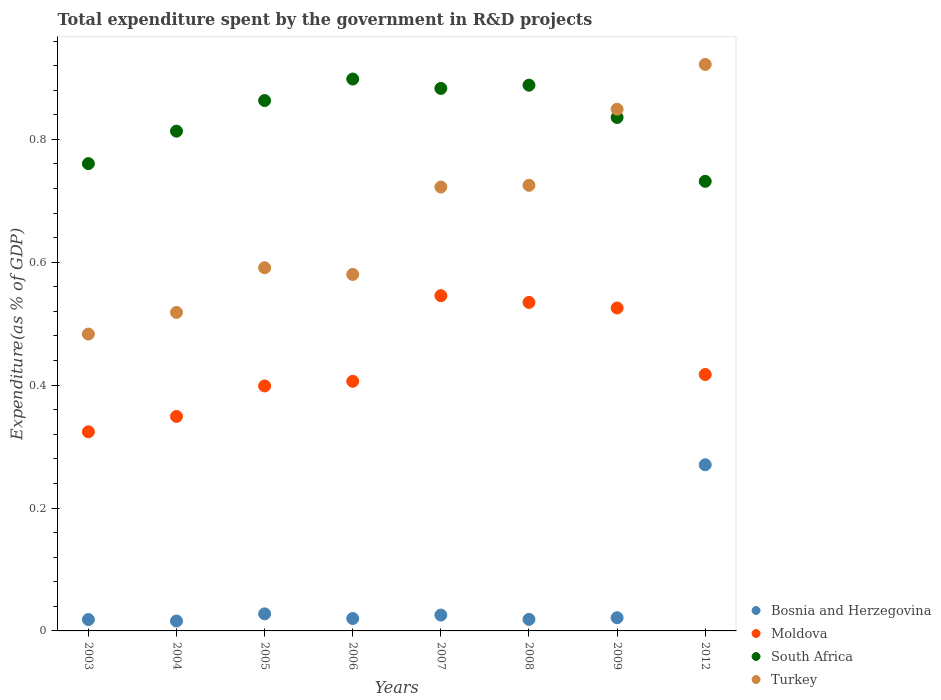What is the total expenditure spent by the government in R&D projects in Turkey in 2007?
Provide a short and direct response. 0.72. Across all years, what is the maximum total expenditure spent by the government in R&D projects in Turkey?
Your response must be concise. 0.92. Across all years, what is the minimum total expenditure spent by the government in R&D projects in Moldova?
Your answer should be very brief. 0.32. In which year was the total expenditure spent by the government in R&D projects in Turkey maximum?
Your answer should be compact. 2012. In which year was the total expenditure spent by the government in R&D projects in Turkey minimum?
Keep it short and to the point. 2003. What is the total total expenditure spent by the government in R&D projects in South Africa in the graph?
Give a very brief answer. 6.67. What is the difference between the total expenditure spent by the government in R&D projects in Bosnia and Herzegovina in 2004 and that in 2012?
Make the answer very short. -0.25. What is the difference between the total expenditure spent by the government in R&D projects in Turkey in 2005 and the total expenditure spent by the government in R&D projects in Moldova in 2008?
Ensure brevity in your answer.  0.06. What is the average total expenditure spent by the government in R&D projects in Turkey per year?
Give a very brief answer. 0.67. In the year 2005, what is the difference between the total expenditure spent by the government in R&D projects in Moldova and total expenditure spent by the government in R&D projects in South Africa?
Your response must be concise. -0.46. In how many years, is the total expenditure spent by the government in R&D projects in South Africa greater than 0.08 %?
Ensure brevity in your answer.  8. What is the ratio of the total expenditure spent by the government in R&D projects in South Africa in 2004 to that in 2009?
Ensure brevity in your answer.  0.97. Is the total expenditure spent by the government in R&D projects in Bosnia and Herzegovina in 2005 less than that in 2008?
Your answer should be very brief. No. What is the difference between the highest and the second highest total expenditure spent by the government in R&D projects in Moldova?
Your answer should be very brief. 0.01. What is the difference between the highest and the lowest total expenditure spent by the government in R&D projects in Moldova?
Your answer should be very brief. 0.22. In how many years, is the total expenditure spent by the government in R&D projects in Bosnia and Herzegovina greater than the average total expenditure spent by the government in R&D projects in Bosnia and Herzegovina taken over all years?
Your answer should be very brief. 1. Is it the case that in every year, the sum of the total expenditure spent by the government in R&D projects in South Africa and total expenditure spent by the government in R&D projects in Bosnia and Herzegovina  is greater than the sum of total expenditure spent by the government in R&D projects in Moldova and total expenditure spent by the government in R&D projects in Turkey?
Provide a short and direct response. No. Is it the case that in every year, the sum of the total expenditure spent by the government in R&D projects in Turkey and total expenditure spent by the government in R&D projects in South Africa  is greater than the total expenditure spent by the government in R&D projects in Bosnia and Herzegovina?
Provide a succinct answer. Yes. Is the total expenditure spent by the government in R&D projects in Moldova strictly greater than the total expenditure spent by the government in R&D projects in Turkey over the years?
Keep it short and to the point. No. How many years are there in the graph?
Your answer should be very brief. 8. What is the difference between two consecutive major ticks on the Y-axis?
Your answer should be compact. 0.2. Are the values on the major ticks of Y-axis written in scientific E-notation?
Give a very brief answer. No. How many legend labels are there?
Provide a succinct answer. 4. What is the title of the graph?
Your response must be concise. Total expenditure spent by the government in R&D projects. Does "Chad" appear as one of the legend labels in the graph?
Offer a terse response. No. What is the label or title of the X-axis?
Make the answer very short. Years. What is the label or title of the Y-axis?
Make the answer very short. Expenditure(as % of GDP). What is the Expenditure(as % of GDP) of Bosnia and Herzegovina in 2003?
Offer a terse response. 0.02. What is the Expenditure(as % of GDP) in Moldova in 2003?
Your response must be concise. 0.32. What is the Expenditure(as % of GDP) in South Africa in 2003?
Keep it short and to the point. 0.76. What is the Expenditure(as % of GDP) of Turkey in 2003?
Ensure brevity in your answer.  0.48. What is the Expenditure(as % of GDP) in Bosnia and Herzegovina in 2004?
Provide a short and direct response. 0.02. What is the Expenditure(as % of GDP) of Moldova in 2004?
Your response must be concise. 0.35. What is the Expenditure(as % of GDP) in South Africa in 2004?
Provide a short and direct response. 0.81. What is the Expenditure(as % of GDP) in Turkey in 2004?
Make the answer very short. 0.52. What is the Expenditure(as % of GDP) of Bosnia and Herzegovina in 2005?
Keep it short and to the point. 0.03. What is the Expenditure(as % of GDP) in Moldova in 2005?
Provide a succinct answer. 0.4. What is the Expenditure(as % of GDP) in South Africa in 2005?
Offer a very short reply. 0.86. What is the Expenditure(as % of GDP) of Turkey in 2005?
Provide a succinct answer. 0.59. What is the Expenditure(as % of GDP) of Bosnia and Herzegovina in 2006?
Offer a terse response. 0.02. What is the Expenditure(as % of GDP) of Moldova in 2006?
Give a very brief answer. 0.41. What is the Expenditure(as % of GDP) of South Africa in 2006?
Provide a succinct answer. 0.9. What is the Expenditure(as % of GDP) in Turkey in 2006?
Offer a very short reply. 0.58. What is the Expenditure(as % of GDP) of Bosnia and Herzegovina in 2007?
Make the answer very short. 0.03. What is the Expenditure(as % of GDP) in Moldova in 2007?
Ensure brevity in your answer.  0.55. What is the Expenditure(as % of GDP) of South Africa in 2007?
Provide a short and direct response. 0.88. What is the Expenditure(as % of GDP) of Turkey in 2007?
Offer a very short reply. 0.72. What is the Expenditure(as % of GDP) in Bosnia and Herzegovina in 2008?
Provide a short and direct response. 0.02. What is the Expenditure(as % of GDP) in Moldova in 2008?
Your answer should be very brief. 0.53. What is the Expenditure(as % of GDP) of South Africa in 2008?
Keep it short and to the point. 0.89. What is the Expenditure(as % of GDP) of Turkey in 2008?
Give a very brief answer. 0.73. What is the Expenditure(as % of GDP) of Bosnia and Herzegovina in 2009?
Offer a terse response. 0.02. What is the Expenditure(as % of GDP) in Moldova in 2009?
Your response must be concise. 0.53. What is the Expenditure(as % of GDP) in South Africa in 2009?
Your response must be concise. 0.84. What is the Expenditure(as % of GDP) of Turkey in 2009?
Provide a short and direct response. 0.85. What is the Expenditure(as % of GDP) in Bosnia and Herzegovina in 2012?
Give a very brief answer. 0.27. What is the Expenditure(as % of GDP) in Moldova in 2012?
Ensure brevity in your answer.  0.42. What is the Expenditure(as % of GDP) in South Africa in 2012?
Give a very brief answer. 0.73. What is the Expenditure(as % of GDP) of Turkey in 2012?
Your answer should be compact. 0.92. Across all years, what is the maximum Expenditure(as % of GDP) of Bosnia and Herzegovina?
Offer a very short reply. 0.27. Across all years, what is the maximum Expenditure(as % of GDP) of Moldova?
Offer a very short reply. 0.55. Across all years, what is the maximum Expenditure(as % of GDP) of South Africa?
Offer a very short reply. 0.9. Across all years, what is the maximum Expenditure(as % of GDP) in Turkey?
Make the answer very short. 0.92. Across all years, what is the minimum Expenditure(as % of GDP) of Bosnia and Herzegovina?
Your answer should be very brief. 0.02. Across all years, what is the minimum Expenditure(as % of GDP) in Moldova?
Your response must be concise. 0.32. Across all years, what is the minimum Expenditure(as % of GDP) in South Africa?
Your response must be concise. 0.73. Across all years, what is the minimum Expenditure(as % of GDP) in Turkey?
Provide a succinct answer. 0.48. What is the total Expenditure(as % of GDP) in Bosnia and Herzegovina in the graph?
Keep it short and to the point. 0.42. What is the total Expenditure(as % of GDP) of Moldova in the graph?
Your answer should be compact. 3.5. What is the total Expenditure(as % of GDP) in South Africa in the graph?
Keep it short and to the point. 6.67. What is the total Expenditure(as % of GDP) of Turkey in the graph?
Your answer should be very brief. 5.39. What is the difference between the Expenditure(as % of GDP) of Bosnia and Herzegovina in 2003 and that in 2004?
Provide a succinct answer. 0. What is the difference between the Expenditure(as % of GDP) of Moldova in 2003 and that in 2004?
Give a very brief answer. -0.03. What is the difference between the Expenditure(as % of GDP) of South Africa in 2003 and that in 2004?
Provide a succinct answer. -0.05. What is the difference between the Expenditure(as % of GDP) of Turkey in 2003 and that in 2004?
Make the answer very short. -0.04. What is the difference between the Expenditure(as % of GDP) of Bosnia and Herzegovina in 2003 and that in 2005?
Offer a terse response. -0.01. What is the difference between the Expenditure(as % of GDP) in Moldova in 2003 and that in 2005?
Your response must be concise. -0.07. What is the difference between the Expenditure(as % of GDP) in South Africa in 2003 and that in 2005?
Provide a short and direct response. -0.1. What is the difference between the Expenditure(as % of GDP) of Turkey in 2003 and that in 2005?
Ensure brevity in your answer.  -0.11. What is the difference between the Expenditure(as % of GDP) of Bosnia and Herzegovina in 2003 and that in 2006?
Keep it short and to the point. -0. What is the difference between the Expenditure(as % of GDP) of Moldova in 2003 and that in 2006?
Offer a terse response. -0.08. What is the difference between the Expenditure(as % of GDP) of South Africa in 2003 and that in 2006?
Your answer should be compact. -0.14. What is the difference between the Expenditure(as % of GDP) of Turkey in 2003 and that in 2006?
Make the answer very short. -0.1. What is the difference between the Expenditure(as % of GDP) of Bosnia and Herzegovina in 2003 and that in 2007?
Provide a succinct answer. -0.01. What is the difference between the Expenditure(as % of GDP) of Moldova in 2003 and that in 2007?
Provide a succinct answer. -0.22. What is the difference between the Expenditure(as % of GDP) in South Africa in 2003 and that in 2007?
Offer a very short reply. -0.12. What is the difference between the Expenditure(as % of GDP) in Turkey in 2003 and that in 2007?
Provide a succinct answer. -0.24. What is the difference between the Expenditure(as % of GDP) of Bosnia and Herzegovina in 2003 and that in 2008?
Make the answer very short. -0. What is the difference between the Expenditure(as % of GDP) in Moldova in 2003 and that in 2008?
Provide a succinct answer. -0.21. What is the difference between the Expenditure(as % of GDP) in South Africa in 2003 and that in 2008?
Offer a very short reply. -0.13. What is the difference between the Expenditure(as % of GDP) of Turkey in 2003 and that in 2008?
Your response must be concise. -0.24. What is the difference between the Expenditure(as % of GDP) in Bosnia and Herzegovina in 2003 and that in 2009?
Ensure brevity in your answer.  -0. What is the difference between the Expenditure(as % of GDP) of Moldova in 2003 and that in 2009?
Provide a short and direct response. -0.2. What is the difference between the Expenditure(as % of GDP) in South Africa in 2003 and that in 2009?
Offer a very short reply. -0.08. What is the difference between the Expenditure(as % of GDP) of Turkey in 2003 and that in 2009?
Offer a terse response. -0.37. What is the difference between the Expenditure(as % of GDP) of Bosnia and Herzegovina in 2003 and that in 2012?
Provide a succinct answer. -0.25. What is the difference between the Expenditure(as % of GDP) in Moldova in 2003 and that in 2012?
Ensure brevity in your answer.  -0.09. What is the difference between the Expenditure(as % of GDP) in South Africa in 2003 and that in 2012?
Keep it short and to the point. 0.03. What is the difference between the Expenditure(as % of GDP) of Turkey in 2003 and that in 2012?
Ensure brevity in your answer.  -0.44. What is the difference between the Expenditure(as % of GDP) in Bosnia and Herzegovina in 2004 and that in 2005?
Your response must be concise. -0.01. What is the difference between the Expenditure(as % of GDP) of Moldova in 2004 and that in 2005?
Your answer should be very brief. -0.05. What is the difference between the Expenditure(as % of GDP) in South Africa in 2004 and that in 2005?
Offer a terse response. -0.05. What is the difference between the Expenditure(as % of GDP) of Turkey in 2004 and that in 2005?
Offer a terse response. -0.07. What is the difference between the Expenditure(as % of GDP) of Bosnia and Herzegovina in 2004 and that in 2006?
Your answer should be compact. -0. What is the difference between the Expenditure(as % of GDP) of Moldova in 2004 and that in 2006?
Make the answer very short. -0.06. What is the difference between the Expenditure(as % of GDP) of South Africa in 2004 and that in 2006?
Provide a short and direct response. -0.08. What is the difference between the Expenditure(as % of GDP) in Turkey in 2004 and that in 2006?
Keep it short and to the point. -0.06. What is the difference between the Expenditure(as % of GDP) of Bosnia and Herzegovina in 2004 and that in 2007?
Make the answer very short. -0.01. What is the difference between the Expenditure(as % of GDP) of Moldova in 2004 and that in 2007?
Provide a succinct answer. -0.2. What is the difference between the Expenditure(as % of GDP) in South Africa in 2004 and that in 2007?
Give a very brief answer. -0.07. What is the difference between the Expenditure(as % of GDP) in Turkey in 2004 and that in 2007?
Provide a succinct answer. -0.2. What is the difference between the Expenditure(as % of GDP) in Bosnia and Herzegovina in 2004 and that in 2008?
Keep it short and to the point. -0. What is the difference between the Expenditure(as % of GDP) in Moldova in 2004 and that in 2008?
Your response must be concise. -0.19. What is the difference between the Expenditure(as % of GDP) in South Africa in 2004 and that in 2008?
Provide a short and direct response. -0.07. What is the difference between the Expenditure(as % of GDP) of Turkey in 2004 and that in 2008?
Offer a terse response. -0.21. What is the difference between the Expenditure(as % of GDP) in Bosnia and Herzegovina in 2004 and that in 2009?
Give a very brief answer. -0.01. What is the difference between the Expenditure(as % of GDP) in Moldova in 2004 and that in 2009?
Your answer should be very brief. -0.18. What is the difference between the Expenditure(as % of GDP) of South Africa in 2004 and that in 2009?
Keep it short and to the point. -0.02. What is the difference between the Expenditure(as % of GDP) in Turkey in 2004 and that in 2009?
Offer a terse response. -0.33. What is the difference between the Expenditure(as % of GDP) in Bosnia and Herzegovina in 2004 and that in 2012?
Keep it short and to the point. -0.25. What is the difference between the Expenditure(as % of GDP) in Moldova in 2004 and that in 2012?
Offer a very short reply. -0.07. What is the difference between the Expenditure(as % of GDP) of South Africa in 2004 and that in 2012?
Your answer should be very brief. 0.08. What is the difference between the Expenditure(as % of GDP) in Turkey in 2004 and that in 2012?
Your response must be concise. -0.4. What is the difference between the Expenditure(as % of GDP) in Bosnia and Herzegovina in 2005 and that in 2006?
Keep it short and to the point. 0.01. What is the difference between the Expenditure(as % of GDP) in Moldova in 2005 and that in 2006?
Ensure brevity in your answer.  -0.01. What is the difference between the Expenditure(as % of GDP) in South Africa in 2005 and that in 2006?
Provide a short and direct response. -0.04. What is the difference between the Expenditure(as % of GDP) of Turkey in 2005 and that in 2006?
Ensure brevity in your answer.  0.01. What is the difference between the Expenditure(as % of GDP) in Bosnia and Herzegovina in 2005 and that in 2007?
Offer a terse response. 0. What is the difference between the Expenditure(as % of GDP) of Moldova in 2005 and that in 2007?
Keep it short and to the point. -0.15. What is the difference between the Expenditure(as % of GDP) in South Africa in 2005 and that in 2007?
Ensure brevity in your answer.  -0.02. What is the difference between the Expenditure(as % of GDP) in Turkey in 2005 and that in 2007?
Make the answer very short. -0.13. What is the difference between the Expenditure(as % of GDP) in Bosnia and Herzegovina in 2005 and that in 2008?
Your answer should be compact. 0.01. What is the difference between the Expenditure(as % of GDP) in Moldova in 2005 and that in 2008?
Your answer should be very brief. -0.14. What is the difference between the Expenditure(as % of GDP) in South Africa in 2005 and that in 2008?
Keep it short and to the point. -0.03. What is the difference between the Expenditure(as % of GDP) of Turkey in 2005 and that in 2008?
Your response must be concise. -0.13. What is the difference between the Expenditure(as % of GDP) of Bosnia and Herzegovina in 2005 and that in 2009?
Give a very brief answer. 0.01. What is the difference between the Expenditure(as % of GDP) in Moldova in 2005 and that in 2009?
Keep it short and to the point. -0.13. What is the difference between the Expenditure(as % of GDP) in South Africa in 2005 and that in 2009?
Your answer should be very brief. 0.03. What is the difference between the Expenditure(as % of GDP) in Turkey in 2005 and that in 2009?
Make the answer very short. -0.26. What is the difference between the Expenditure(as % of GDP) of Bosnia and Herzegovina in 2005 and that in 2012?
Your answer should be compact. -0.24. What is the difference between the Expenditure(as % of GDP) in Moldova in 2005 and that in 2012?
Keep it short and to the point. -0.02. What is the difference between the Expenditure(as % of GDP) in South Africa in 2005 and that in 2012?
Your answer should be compact. 0.13. What is the difference between the Expenditure(as % of GDP) of Turkey in 2005 and that in 2012?
Provide a succinct answer. -0.33. What is the difference between the Expenditure(as % of GDP) of Bosnia and Herzegovina in 2006 and that in 2007?
Give a very brief answer. -0.01. What is the difference between the Expenditure(as % of GDP) in Moldova in 2006 and that in 2007?
Your answer should be very brief. -0.14. What is the difference between the Expenditure(as % of GDP) of South Africa in 2006 and that in 2007?
Keep it short and to the point. 0.02. What is the difference between the Expenditure(as % of GDP) in Turkey in 2006 and that in 2007?
Provide a succinct answer. -0.14. What is the difference between the Expenditure(as % of GDP) of Bosnia and Herzegovina in 2006 and that in 2008?
Ensure brevity in your answer.  0. What is the difference between the Expenditure(as % of GDP) in Moldova in 2006 and that in 2008?
Provide a short and direct response. -0.13. What is the difference between the Expenditure(as % of GDP) of South Africa in 2006 and that in 2008?
Provide a succinct answer. 0.01. What is the difference between the Expenditure(as % of GDP) of Turkey in 2006 and that in 2008?
Your answer should be compact. -0.14. What is the difference between the Expenditure(as % of GDP) in Bosnia and Herzegovina in 2006 and that in 2009?
Give a very brief answer. -0. What is the difference between the Expenditure(as % of GDP) in Moldova in 2006 and that in 2009?
Ensure brevity in your answer.  -0.12. What is the difference between the Expenditure(as % of GDP) of South Africa in 2006 and that in 2009?
Provide a succinct answer. 0.06. What is the difference between the Expenditure(as % of GDP) of Turkey in 2006 and that in 2009?
Your answer should be compact. -0.27. What is the difference between the Expenditure(as % of GDP) of Bosnia and Herzegovina in 2006 and that in 2012?
Your answer should be very brief. -0.25. What is the difference between the Expenditure(as % of GDP) of Moldova in 2006 and that in 2012?
Offer a terse response. -0.01. What is the difference between the Expenditure(as % of GDP) of South Africa in 2006 and that in 2012?
Provide a short and direct response. 0.17. What is the difference between the Expenditure(as % of GDP) of Turkey in 2006 and that in 2012?
Provide a succinct answer. -0.34. What is the difference between the Expenditure(as % of GDP) in Bosnia and Herzegovina in 2007 and that in 2008?
Provide a short and direct response. 0.01. What is the difference between the Expenditure(as % of GDP) of Moldova in 2007 and that in 2008?
Your answer should be compact. 0.01. What is the difference between the Expenditure(as % of GDP) in South Africa in 2007 and that in 2008?
Your response must be concise. -0.01. What is the difference between the Expenditure(as % of GDP) of Turkey in 2007 and that in 2008?
Your answer should be compact. -0. What is the difference between the Expenditure(as % of GDP) of Bosnia and Herzegovina in 2007 and that in 2009?
Your response must be concise. 0. What is the difference between the Expenditure(as % of GDP) in Moldova in 2007 and that in 2009?
Keep it short and to the point. 0.02. What is the difference between the Expenditure(as % of GDP) of South Africa in 2007 and that in 2009?
Your response must be concise. 0.05. What is the difference between the Expenditure(as % of GDP) of Turkey in 2007 and that in 2009?
Keep it short and to the point. -0.13. What is the difference between the Expenditure(as % of GDP) in Bosnia and Herzegovina in 2007 and that in 2012?
Offer a very short reply. -0.24. What is the difference between the Expenditure(as % of GDP) in Moldova in 2007 and that in 2012?
Offer a very short reply. 0.13. What is the difference between the Expenditure(as % of GDP) in South Africa in 2007 and that in 2012?
Ensure brevity in your answer.  0.15. What is the difference between the Expenditure(as % of GDP) of Turkey in 2007 and that in 2012?
Provide a short and direct response. -0.2. What is the difference between the Expenditure(as % of GDP) in Bosnia and Herzegovina in 2008 and that in 2009?
Provide a short and direct response. -0. What is the difference between the Expenditure(as % of GDP) of Moldova in 2008 and that in 2009?
Ensure brevity in your answer.  0.01. What is the difference between the Expenditure(as % of GDP) of South Africa in 2008 and that in 2009?
Your response must be concise. 0.05. What is the difference between the Expenditure(as % of GDP) in Turkey in 2008 and that in 2009?
Your response must be concise. -0.12. What is the difference between the Expenditure(as % of GDP) in Bosnia and Herzegovina in 2008 and that in 2012?
Your answer should be compact. -0.25. What is the difference between the Expenditure(as % of GDP) in Moldova in 2008 and that in 2012?
Your answer should be compact. 0.12. What is the difference between the Expenditure(as % of GDP) in South Africa in 2008 and that in 2012?
Offer a very short reply. 0.16. What is the difference between the Expenditure(as % of GDP) in Turkey in 2008 and that in 2012?
Your answer should be compact. -0.2. What is the difference between the Expenditure(as % of GDP) in Bosnia and Herzegovina in 2009 and that in 2012?
Your answer should be very brief. -0.25. What is the difference between the Expenditure(as % of GDP) in Moldova in 2009 and that in 2012?
Provide a short and direct response. 0.11. What is the difference between the Expenditure(as % of GDP) of South Africa in 2009 and that in 2012?
Provide a short and direct response. 0.1. What is the difference between the Expenditure(as % of GDP) of Turkey in 2009 and that in 2012?
Provide a succinct answer. -0.07. What is the difference between the Expenditure(as % of GDP) in Bosnia and Herzegovina in 2003 and the Expenditure(as % of GDP) in Moldova in 2004?
Give a very brief answer. -0.33. What is the difference between the Expenditure(as % of GDP) of Bosnia and Herzegovina in 2003 and the Expenditure(as % of GDP) of South Africa in 2004?
Keep it short and to the point. -0.79. What is the difference between the Expenditure(as % of GDP) of Bosnia and Herzegovina in 2003 and the Expenditure(as % of GDP) of Turkey in 2004?
Offer a very short reply. -0.5. What is the difference between the Expenditure(as % of GDP) of Moldova in 2003 and the Expenditure(as % of GDP) of South Africa in 2004?
Ensure brevity in your answer.  -0.49. What is the difference between the Expenditure(as % of GDP) in Moldova in 2003 and the Expenditure(as % of GDP) in Turkey in 2004?
Give a very brief answer. -0.19. What is the difference between the Expenditure(as % of GDP) in South Africa in 2003 and the Expenditure(as % of GDP) in Turkey in 2004?
Offer a terse response. 0.24. What is the difference between the Expenditure(as % of GDP) in Bosnia and Herzegovina in 2003 and the Expenditure(as % of GDP) in Moldova in 2005?
Ensure brevity in your answer.  -0.38. What is the difference between the Expenditure(as % of GDP) of Bosnia and Herzegovina in 2003 and the Expenditure(as % of GDP) of South Africa in 2005?
Provide a short and direct response. -0.84. What is the difference between the Expenditure(as % of GDP) of Bosnia and Herzegovina in 2003 and the Expenditure(as % of GDP) of Turkey in 2005?
Your answer should be very brief. -0.57. What is the difference between the Expenditure(as % of GDP) of Moldova in 2003 and the Expenditure(as % of GDP) of South Africa in 2005?
Your answer should be very brief. -0.54. What is the difference between the Expenditure(as % of GDP) in Moldova in 2003 and the Expenditure(as % of GDP) in Turkey in 2005?
Ensure brevity in your answer.  -0.27. What is the difference between the Expenditure(as % of GDP) in South Africa in 2003 and the Expenditure(as % of GDP) in Turkey in 2005?
Make the answer very short. 0.17. What is the difference between the Expenditure(as % of GDP) in Bosnia and Herzegovina in 2003 and the Expenditure(as % of GDP) in Moldova in 2006?
Offer a very short reply. -0.39. What is the difference between the Expenditure(as % of GDP) of Bosnia and Herzegovina in 2003 and the Expenditure(as % of GDP) of South Africa in 2006?
Make the answer very short. -0.88. What is the difference between the Expenditure(as % of GDP) of Bosnia and Herzegovina in 2003 and the Expenditure(as % of GDP) of Turkey in 2006?
Your response must be concise. -0.56. What is the difference between the Expenditure(as % of GDP) in Moldova in 2003 and the Expenditure(as % of GDP) in South Africa in 2006?
Your answer should be compact. -0.57. What is the difference between the Expenditure(as % of GDP) in Moldova in 2003 and the Expenditure(as % of GDP) in Turkey in 2006?
Give a very brief answer. -0.26. What is the difference between the Expenditure(as % of GDP) of South Africa in 2003 and the Expenditure(as % of GDP) of Turkey in 2006?
Offer a terse response. 0.18. What is the difference between the Expenditure(as % of GDP) of Bosnia and Herzegovina in 2003 and the Expenditure(as % of GDP) of Moldova in 2007?
Make the answer very short. -0.53. What is the difference between the Expenditure(as % of GDP) in Bosnia and Herzegovina in 2003 and the Expenditure(as % of GDP) in South Africa in 2007?
Ensure brevity in your answer.  -0.86. What is the difference between the Expenditure(as % of GDP) in Bosnia and Herzegovina in 2003 and the Expenditure(as % of GDP) in Turkey in 2007?
Ensure brevity in your answer.  -0.7. What is the difference between the Expenditure(as % of GDP) of Moldova in 2003 and the Expenditure(as % of GDP) of South Africa in 2007?
Make the answer very short. -0.56. What is the difference between the Expenditure(as % of GDP) in Moldova in 2003 and the Expenditure(as % of GDP) in Turkey in 2007?
Make the answer very short. -0.4. What is the difference between the Expenditure(as % of GDP) of South Africa in 2003 and the Expenditure(as % of GDP) of Turkey in 2007?
Your answer should be very brief. 0.04. What is the difference between the Expenditure(as % of GDP) in Bosnia and Herzegovina in 2003 and the Expenditure(as % of GDP) in Moldova in 2008?
Provide a succinct answer. -0.52. What is the difference between the Expenditure(as % of GDP) in Bosnia and Herzegovina in 2003 and the Expenditure(as % of GDP) in South Africa in 2008?
Offer a very short reply. -0.87. What is the difference between the Expenditure(as % of GDP) of Bosnia and Herzegovina in 2003 and the Expenditure(as % of GDP) of Turkey in 2008?
Offer a very short reply. -0.71. What is the difference between the Expenditure(as % of GDP) of Moldova in 2003 and the Expenditure(as % of GDP) of South Africa in 2008?
Your answer should be compact. -0.56. What is the difference between the Expenditure(as % of GDP) in Moldova in 2003 and the Expenditure(as % of GDP) in Turkey in 2008?
Give a very brief answer. -0.4. What is the difference between the Expenditure(as % of GDP) of South Africa in 2003 and the Expenditure(as % of GDP) of Turkey in 2008?
Make the answer very short. 0.04. What is the difference between the Expenditure(as % of GDP) in Bosnia and Herzegovina in 2003 and the Expenditure(as % of GDP) in Moldova in 2009?
Your answer should be very brief. -0.51. What is the difference between the Expenditure(as % of GDP) of Bosnia and Herzegovina in 2003 and the Expenditure(as % of GDP) of South Africa in 2009?
Offer a very short reply. -0.82. What is the difference between the Expenditure(as % of GDP) in Bosnia and Herzegovina in 2003 and the Expenditure(as % of GDP) in Turkey in 2009?
Your answer should be very brief. -0.83. What is the difference between the Expenditure(as % of GDP) in Moldova in 2003 and the Expenditure(as % of GDP) in South Africa in 2009?
Your answer should be compact. -0.51. What is the difference between the Expenditure(as % of GDP) of Moldova in 2003 and the Expenditure(as % of GDP) of Turkey in 2009?
Ensure brevity in your answer.  -0.53. What is the difference between the Expenditure(as % of GDP) in South Africa in 2003 and the Expenditure(as % of GDP) in Turkey in 2009?
Keep it short and to the point. -0.09. What is the difference between the Expenditure(as % of GDP) in Bosnia and Herzegovina in 2003 and the Expenditure(as % of GDP) in Moldova in 2012?
Your answer should be very brief. -0.4. What is the difference between the Expenditure(as % of GDP) of Bosnia and Herzegovina in 2003 and the Expenditure(as % of GDP) of South Africa in 2012?
Keep it short and to the point. -0.71. What is the difference between the Expenditure(as % of GDP) in Bosnia and Herzegovina in 2003 and the Expenditure(as % of GDP) in Turkey in 2012?
Offer a terse response. -0.9. What is the difference between the Expenditure(as % of GDP) of Moldova in 2003 and the Expenditure(as % of GDP) of South Africa in 2012?
Make the answer very short. -0.41. What is the difference between the Expenditure(as % of GDP) in Moldova in 2003 and the Expenditure(as % of GDP) in Turkey in 2012?
Provide a succinct answer. -0.6. What is the difference between the Expenditure(as % of GDP) of South Africa in 2003 and the Expenditure(as % of GDP) of Turkey in 2012?
Offer a terse response. -0.16. What is the difference between the Expenditure(as % of GDP) in Bosnia and Herzegovina in 2004 and the Expenditure(as % of GDP) in Moldova in 2005?
Keep it short and to the point. -0.38. What is the difference between the Expenditure(as % of GDP) in Bosnia and Herzegovina in 2004 and the Expenditure(as % of GDP) in South Africa in 2005?
Ensure brevity in your answer.  -0.85. What is the difference between the Expenditure(as % of GDP) in Bosnia and Herzegovina in 2004 and the Expenditure(as % of GDP) in Turkey in 2005?
Your response must be concise. -0.57. What is the difference between the Expenditure(as % of GDP) in Moldova in 2004 and the Expenditure(as % of GDP) in South Africa in 2005?
Offer a terse response. -0.51. What is the difference between the Expenditure(as % of GDP) of Moldova in 2004 and the Expenditure(as % of GDP) of Turkey in 2005?
Ensure brevity in your answer.  -0.24. What is the difference between the Expenditure(as % of GDP) in South Africa in 2004 and the Expenditure(as % of GDP) in Turkey in 2005?
Give a very brief answer. 0.22. What is the difference between the Expenditure(as % of GDP) in Bosnia and Herzegovina in 2004 and the Expenditure(as % of GDP) in Moldova in 2006?
Provide a succinct answer. -0.39. What is the difference between the Expenditure(as % of GDP) of Bosnia and Herzegovina in 2004 and the Expenditure(as % of GDP) of South Africa in 2006?
Make the answer very short. -0.88. What is the difference between the Expenditure(as % of GDP) in Bosnia and Herzegovina in 2004 and the Expenditure(as % of GDP) in Turkey in 2006?
Provide a short and direct response. -0.56. What is the difference between the Expenditure(as % of GDP) of Moldova in 2004 and the Expenditure(as % of GDP) of South Africa in 2006?
Ensure brevity in your answer.  -0.55. What is the difference between the Expenditure(as % of GDP) in Moldova in 2004 and the Expenditure(as % of GDP) in Turkey in 2006?
Keep it short and to the point. -0.23. What is the difference between the Expenditure(as % of GDP) of South Africa in 2004 and the Expenditure(as % of GDP) of Turkey in 2006?
Your answer should be very brief. 0.23. What is the difference between the Expenditure(as % of GDP) of Bosnia and Herzegovina in 2004 and the Expenditure(as % of GDP) of Moldova in 2007?
Give a very brief answer. -0.53. What is the difference between the Expenditure(as % of GDP) of Bosnia and Herzegovina in 2004 and the Expenditure(as % of GDP) of South Africa in 2007?
Give a very brief answer. -0.87. What is the difference between the Expenditure(as % of GDP) in Bosnia and Herzegovina in 2004 and the Expenditure(as % of GDP) in Turkey in 2007?
Your response must be concise. -0.71. What is the difference between the Expenditure(as % of GDP) in Moldova in 2004 and the Expenditure(as % of GDP) in South Africa in 2007?
Provide a short and direct response. -0.53. What is the difference between the Expenditure(as % of GDP) of Moldova in 2004 and the Expenditure(as % of GDP) of Turkey in 2007?
Provide a succinct answer. -0.37. What is the difference between the Expenditure(as % of GDP) in South Africa in 2004 and the Expenditure(as % of GDP) in Turkey in 2007?
Provide a short and direct response. 0.09. What is the difference between the Expenditure(as % of GDP) of Bosnia and Herzegovina in 2004 and the Expenditure(as % of GDP) of Moldova in 2008?
Offer a very short reply. -0.52. What is the difference between the Expenditure(as % of GDP) of Bosnia and Herzegovina in 2004 and the Expenditure(as % of GDP) of South Africa in 2008?
Ensure brevity in your answer.  -0.87. What is the difference between the Expenditure(as % of GDP) in Bosnia and Herzegovina in 2004 and the Expenditure(as % of GDP) in Turkey in 2008?
Provide a short and direct response. -0.71. What is the difference between the Expenditure(as % of GDP) of Moldova in 2004 and the Expenditure(as % of GDP) of South Africa in 2008?
Provide a succinct answer. -0.54. What is the difference between the Expenditure(as % of GDP) of Moldova in 2004 and the Expenditure(as % of GDP) of Turkey in 2008?
Make the answer very short. -0.38. What is the difference between the Expenditure(as % of GDP) of South Africa in 2004 and the Expenditure(as % of GDP) of Turkey in 2008?
Offer a very short reply. 0.09. What is the difference between the Expenditure(as % of GDP) of Bosnia and Herzegovina in 2004 and the Expenditure(as % of GDP) of Moldova in 2009?
Offer a very short reply. -0.51. What is the difference between the Expenditure(as % of GDP) in Bosnia and Herzegovina in 2004 and the Expenditure(as % of GDP) in South Africa in 2009?
Provide a succinct answer. -0.82. What is the difference between the Expenditure(as % of GDP) in Bosnia and Herzegovina in 2004 and the Expenditure(as % of GDP) in Turkey in 2009?
Give a very brief answer. -0.83. What is the difference between the Expenditure(as % of GDP) of Moldova in 2004 and the Expenditure(as % of GDP) of South Africa in 2009?
Offer a terse response. -0.49. What is the difference between the Expenditure(as % of GDP) of Moldova in 2004 and the Expenditure(as % of GDP) of Turkey in 2009?
Offer a terse response. -0.5. What is the difference between the Expenditure(as % of GDP) in South Africa in 2004 and the Expenditure(as % of GDP) in Turkey in 2009?
Your answer should be compact. -0.04. What is the difference between the Expenditure(as % of GDP) of Bosnia and Herzegovina in 2004 and the Expenditure(as % of GDP) of Moldova in 2012?
Give a very brief answer. -0.4. What is the difference between the Expenditure(as % of GDP) in Bosnia and Herzegovina in 2004 and the Expenditure(as % of GDP) in South Africa in 2012?
Your response must be concise. -0.72. What is the difference between the Expenditure(as % of GDP) of Bosnia and Herzegovina in 2004 and the Expenditure(as % of GDP) of Turkey in 2012?
Offer a very short reply. -0.91. What is the difference between the Expenditure(as % of GDP) of Moldova in 2004 and the Expenditure(as % of GDP) of South Africa in 2012?
Keep it short and to the point. -0.38. What is the difference between the Expenditure(as % of GDP) of Moldova in 2004 and the Expenditure(as % of GDP) of Turkey in 2012?
Provide a short and direct response. -0.57. What is the difference between the Expenditure(as % of GDP) in South Africa in 2004 and the Expenditure(as % of GDP) in Turkey in 2012?
Provide a succinct answer. -0.11. What is the difference between the Expenditure(as % of GDP) of Bosnia and Herzegovina in 2005 and the Expenditure(as % of GDP) of Moldova in 2006?
Your answer should be very brief. -0.38. What is the difference between the Expenditure(as % of GDP) of Bosnia and Herzegovina in 2005 and the Expenditure(as % of GDP) of South Africa in 2006?
Keep it short and to the point. -0.87. What is the difference between the Expenditure(as % of GDP) in Bosnia and Herzegovina in 2005 and the Expenditure(as % of GDP) in Turkey in 2006?
Ensure brevity in your answer.  -0.55. What is the difference between the Expenditure(as % of GDP) in Moldova in 2005 and the Expenditure(as % of GDP) in South Africa in 2006?
Provide a short and direct response. -0.5. What is the difference between the Expenditure(as % of GDP) in Moldova in 2005 and the Expenditure(as % of GDP) in Turkey in 2006?
Give a very brief answer. -0.18. What is the difference between the Expenditure(as % of GDP) of South Africa in 2005 and the Expenditure(as % of GDP) of Turkey in 2006?
Provide a short and direct response. 0.28. What is the difference between the Expenditure(as % of GDP) of Bosnia and Herzegovina in 2005 and the Expenditure(as % of GDP) of Moldova in 2007?
Provide a succinct answer. -0.52. What is the difference between the Expenditure(as % of GDP) of Bosnia and Herzegovina in 2005 and the Expenditure(as % of GDP) of South Africa in 2007?
Ensure brevity in your answer.  -0.86. What is the difference between the Expenditure(as % of GDP) of Bosnia and Herzegovina in 2005 and the Expenditure(as % of GDP) of Turkey in 2007?
Your answer should be very brief. -0.69. What is the difference between the Expenditure(as % of GDP) in Moldova in 2005 and the Expenditure(as % of GDP) in South Africa in 2007?
Give a very brief answer. -0.48. What is the difference between the Expenditure(as % of GDP) of Moldova in 2005 and the Expenditure(as % of GDP) of Turkey in 2007?
Provide a succinct answer. -0.32. What is the difference between the Expenditure(as % of GDP) of South Africa in 2005 and the Expenditure(as % of GDP) of Turkey in 2007?
Your answer should be very brief. 0.14. What is the difference between the Expenditure(as % of GDP) of Bosnia and Herzegovina in 2005 and the Expenditure(as % of GDP) of Moldova in 2008?
Provide a short and direct response. -0.51. What is the difference between the Expenditure(as % of GDP) in Bosnia and Herzegovina in 2005 and the Expenditure(as % of GDP) in South Africa in 2008?
Your answer should be very brief. -0.86. What is the difference between the Expenditure(as % of GDP) in Bosnia and Herzegovina in 2005 and the Expenditure(as % of GDP) in Turkey in 2008?
Your answer should be compact. -0.7. What is the difference between the Expenditure(as % of GDP) in Moldova in 2005 and the Expenditure(as % of GDP) in South Africa in 2008?
Make the answer very short. -0.49. What is the difference between the Expenditure(as % of GDP) in Moldova in 2005 and the Expenditure(as % of GDP) in Turkey in 2008?
Make the answer very short. -0.33. What is the difference between the Expenditure(as % of GDP) of South Africa in 2005 and the Expenditure(as % of GDP) of Turkey in 2008?
Provide a short and direct response. 0.14. What is the difference between the Expenditure(as % of GDP) in Bosnia and Herzegovina in 2005 and the Expenditure(as % of GDP) in Moldova in 2009?
Ensure brevity in your answer.  -0.5. What is the difference between the Expenditure(as % of GDP) in Bosnia and Herzegovina in 2005 and the Expenditure(as % of GDP) in South Africa in 2009?
Provide a succinct answer. -0.81. What is the difference between the Expenditure(as % of GDP) in Bosnia and Herzegovina in 2005 and the Expenditure(as % of GDP) in Turkey in 2009?
Your response must be concise. -0.82. What is the difference between the Expenditure(as % of GDP) in Moldova in 2005 and the Expenditure(as % of GDP) in South Africa in 2009?
Keep it short and to the point. -0.44. What is the difference between the Expenditure(as % of GDP) of Moldova in 2005 and the Expenditure(as % of GDP) of Turkey in 2009?
Ensure brevity in your answer.  -0.45. What is the difference between the Expenditure(as % of GDP) in South Africa in 2005 and the Expenditure(as % of GDP) in Turkey in 2009?
Make the answer very short. 0.01. What is the difference between the Expenditure(as % of GDP) in Bosnia and Herzegovina in 2005 and the Expenditure(as % of GDP) in Moldova in 2012?
Ensure brevity in your answer.  -0.39. What is the difference between the Expenditure(as % of GDP) in Bosnia and Herzegovina in 2005 and the Expenditure(as % of GDP) in South Africa in 2012?
Provide a short and direct response. -0.7. What is the difference between the Expenditure(as % of GDP) of Bosnia and Herzegovina in 2005 and the Expenditure(as % of GDP) of Turkey in 2012?
Keep it short and to the point. -0.89. What is the difference between the Expenditure(as % of GDP) of Moldova in 2005 and the Expenditure(as % of GDP) of South Africa in 2012?
Give a very brief answer. -0.33. What is the difference between the Expenditure(as % of GDP) in Moldova in 2005 and the Expenditure(as % of GDP) in Turkey in 2012?
Make the answer very short. -0.52. What is the difference between the Expenditure(as % of GDP) of South Africa in 2005 and the Expenditure(as % of GDP) of Turkey in 2012?
Keep it short and to the point. -0.06. What is the difference between the Expenditure(as % of GDP) in Bosnia and Herzegovina in 2006 and the Expenditure(as % of GDP) in Moldova in 2007?
Keep it short and to the point. -0.53. What is the difference between the Expenditure(as % of GDP) of Bosnia and Herzegovina in 2006 and the Expenditure(as % of GDP) of South Africa in 2007?
Your response must be concise. -0.86. What is the difference between the Expenditure(as % of GDP) in Bosnia and Herzegovina in 2006 and the Expenditure(as % of GDP) in Turkey in 2007?
Your response must be concise. -0.7. What is the difference between the Expenditure(as % of GDP) of Moldova in 2006 and the Expenditure(as % of GDP) of South Africa in 2007?
Offer a terse response. -0.48. What is the difference between the Expenditure(as % of GDP) in Moldova in 2006 and the Expenditure(as % of GDP) in Turkey in 2007?
Offer a very short reply. -0.32. What is the difference between the Expenditure(as % of GDP) in South Africa in 2006 and the Expenditure(as % of GDP) in Turkey in 2007?
Offer a terse response. 0.18. What is the difference between the Expenditure(as % of GDP) in Bosnia and Herzegovina in 2006 and the Expenditure(as % of GDP) in Moldova in 2008?
Your answer should be compact. -0.51. What is the difference between the Expenditure(as % of GDP) in Bosnia and Herzegovina in 2006 and the Expenditure(as % of GDP) in South Africa in 2008?
Offer a very short reply. -0.87. What is the difference between the Expenditure(as % of GDP) of Bosnia and Herzegovina in 2006 and the Expenditure(as % of GDP) of Turkey in 2008?
Ensure brevity in your answer.  -0.7. What is the difference between the Expenditure(as % of GDP) of Moldova in 2006 and the Expenditure(as % of GDP) of South Africa in 2008?
Your answer should be compact. -0.48. What is the difference between the Expenditure(as % of GDP) in Moldova in 2006 and the Expenditure(as % of GDP) in Turkey in 2008?
Offer a terse response. -0.32. What is the difference between the Expenditure(as % of GDP) of South Africa in 2006 and the Expenditure(as % of GDP) of Turkey in 2008?
Your answer should be compact. 0.17. What is the difference between the Expenditure(as % of GDP) of Bosnia and Herzegovina in 2006 and the Expenditure(as % of GDP) of Moldova in 2009?
Your response must be concise. -0.51. What is the difference between the Expenditure(as % of GDP) of Bosnia and Herzegovina in 2006 and the Expenditure(as % of GDP) of South Africa in 2009?
Your answer should be very brief. -0.82. What is the difference between the Expenditure(as % of GDP) in Bosnia and Herzegovina in 2006 and the Expenditure(as % of GDP) in Turkey in 2009?
Keep it short and to the point. -0.83. What is the difference between the Expenditure(as % of GDP) of Moldova in 2006 and the Expenditure(as % of GDP) of South Africa in 2009?
Offer a terse response. -0.43. What is the difference between the Expenditure(as % of GDP) in Moldova in 2006 and the Expenditure(as % of GDP) in Turkey in 2009?
Offer a very short reply. -0.44. What is the difference between the Expenditure(as % of GDP) of South Africa in 2006 and the Expenditure(as % of GDP) of Turkey in 2009?
Your response must be concise. 0.05. What is the difference between the Expenditure(as % of GDP) of Bosnia and Herzegovina in 2006 and the Expenditure(as % of GDP) of Moldova in 2012?
Your answer should be compact. -0.4. What is the difference between the Expenditure(as % of GDP) of Bosnia and Herzegovina in 2006 and the Expenditure(as % of GDP) of South Africa in 2012?
Your answer should be very brief. -0.71. What is the difference between the Expenditure(as % of GDP) of Bosnia and Herzegovina in 2006 and the Expenditure(as % of GDP) of Turkey in 2012?
Make the answer very short. -0.9. What is the difference between the Expenditure(as % of GDP) of Moldova in 2006 and the Expenditure(as % of GDP) of South Africa in 2012?
Offer a very short reply. -0.33. What is the difference between the Expenditure(as % of GDP) in Moldova in 2006 and the Expenditure(as % of GDP) in Turkey in 2012?
Make the answer very short. -0.52. What is the difference between the Expenditure(as % of GDP) of South Africa in 2006 and the Expenditure(as % of GDP) of Turkey in 2012?
Provide a succinct answer. -0.02. What is the difference between the Expenditure(as % of GDP) of Bosnia and Herzegovina in 2007 and the Expenditure(as % of GDP) of Moldova in 2008?
Keep it short and to the point. -0.51. What is the difference between the Expenditure(as % of GDP) of Bosnia and Herzegovina in 2007 and the Expenditure(as % of GDP) of South Africa in 2008?
Your response must be concise. -0.86. What is the difference between the Expenditure(as % of GDP) of Bosnia and Herzegovina in 2007 and the Expenditure(as % of GDP) of Turkey in 2008?
Offer a very short reply. -0.7. What is the difference between the Expenditure(as % of GDP) of Moldova in 2007 and the Expenditure(as % of GDP) of South Africa in 2008?
Your answer should be compact. -0.34. What is the difference between the Expenditure(as % of GDP) of Moldova in 2007 and the Expenditure(as % of GDP) of Turkey in 2008?
Give a very brief answer. -0.18. What is the difference between the Expenditure(as % of GDP) of South Africa in 2007 and the Expenditure(as % of GDP) of Turkey in 2008?
Ensure brevity in your answer.  0.16. What is the difference between the Expenditure(as % of GDP) in Bosnia and Herzegovina in 2007 and the Expenditure(as % of GDP) in Moldova in 2009?
Make the answer very short. -0.5. What is the difference between the Expenditure(as % of GDP) in Bosnia and Herzegovina in 2007 and the Expenditure(as % of GDP) in South Africa in 2009?
Ensure brevity in your answer.  -0.81. What is the difference between the Expenditure(as % of GDP) of Bosnia and Herzegovina in 2007 and the Expenditure(as % of GDP) of Turkey in 2009?
Give a very brief answer. -0.82. What is the difference between the Expenditure(as % of GDP) in Moldova in 2007 and the Expenditure(as % of GDP) in South Africa in 2009?
Your response must be concise. -0.29. What is the difference between the Expenditure(as % of GDP) in Moldova in 2007 and the Expenditure(as % of GDP) in Turkey in 2009?
Make the answer very short. -0.3. What is the difference between the Expenditure(as % of GDP) of South Africa in 2007 and the Expenditure(as % of GDP) of Turkey in 2009?
Ensure brevity in your answer.  0.03. What is the difference between the Expenditure(as % of GDP) of Bosnia and Herzegovina in 2007 and the Expenditure(as % of GDP) of Moldova in 2012?
Offer a very short reply. -0.39. What is the difference between the Expenditure(as % of GDP) of Bosnia and Herzegovina in 2007 and the Expenditure(as % of GDP) of South Africa in 2012?
Provide a succinct answer. -0.71. What is the difference between the Expenditure(as % of GDP) of Bosnia and Herzegovina in 2007 and the Expenditure(as % of GDP) of Turkey in 2012?
Ensure brevity in your answer.  -0.9. What is the difference between the Expenditure(as % of GDP) of Moldova in 2007 and the Expenditure(as % of GDP) of South Africa in 2012?
Your answer should be compact. -0.19. What is the difference between the Expenditure(as % of GDP) of Moldova in 2007 and the Expenditure(as % of GDP) of Turkey in 2012?
Your response must be concise. -0.38. What is the difference between the Expenditure(as % of GDP) in South Africa in 2007 and the Expenditure(as % of GDP) in Turkey in 2012?
Give a very brief answer. -0.04. What is the difference between the Expenditure(as % of GDP) in Bosnia and Herzegovina in 2008 and the Expenditure(as % of GDP) in Moldova in 2009?
Provide a succinct answer. -0.51. What is the difference between the Expenditure(as % of GDP) in Bosnia and Herzegovina in 2008 and the Expenditure(as % of GDP) in South Africa in 2009?
Your answer should be compact. -0.82. What is the difference between the Expenditure(as % of GDP) in Bosnia and Herzegovina in 2008 and the Expenditure(as % of GDP) in Turkey in 2009?
Your response must be concise. -0.83. What is the difference between the Expenditure(as % of GDP) in Moldova in 2008 and the Expenditure(as % of GDP) in South Africa in 2009?
Provide a succinct answer. -0.3. What is the difference between the Expenditure(as % of GDP) in Moldova in 2008 and the Expenditure(as % of GDP) in Turkey in 2009?
Make the answer very short. -0.31. What is the difference between the Expenditure(as % of GDP) in South Africa in 2008 and the Expenditure(as % of GDP) in Turkey in 2009?
Your answer should be compact. 0.04. What is the difference between the Expenditure(as % of GDP) in Bosnia and Herzegovina in 2008 and the Expenditure(as % of GDP) in Moldova in 2012?
Keep it short and to the point. -0.4. What is the difference between the Expenditure(as % of GDP) of Bosnia and Herzegovina in 2008 and the Expenditure(as % of GDP) of South Africa in 2012?
Your response must be concise. -0.71. What is the difference between the Expenditure(as % of GDP) of Bosnia and Herzegovina in 2008 and the Expenditure(as % of GDP) of Turkey in 2012?
Give a very brief answer. -0.9. What is the difference between the Expenditure(as % of GDP) of Moldova in 2008 and the Expenditure(as % of GDP) of South Africa in 2012?
Offer a terse response. -0.2. What is the difference between the Expenditure(as % of GDP) in Moldova in 2008 and the Expenditure(as % of GDP) in Turkey in 2012?
Give a very brief answer. -0.39. What is the difference between the Expenditure(as % of GDP) of South Africa in 2008 and the Expenditure(as % of GDP) of Turkey in 2012?
Give a very brief answer. -0.03. What is the difference between the Expenditure(as % of GDP) in Bosnia and Herzegovina in 2009 and the Expenditure(as % of GDP) in Moldova in 2012?
Your answer should be compact. -0.4. What is the difference between the Expenditure(as % of GDP) in Bosnia and Herzegovina in 2009 and the Expenditure(as % of GDP) in South Africa in 2012?
Provide a short and direct response. -0.71. What is the difference between the Expenditure(as % of GDP) in Bosnia and Herzegovina in 2009 and the Expenditure(as % of GDP) in Turkey in 2012?
Give a very brief answer. -0.9. What is the difference between the Expenditure(as % of GDP) of Moldova in 2009 and the Expenditure(as % of GDP) of South Africa in 2012?
Provide a succinct answer. -0.21. What is the difference between the Expenditure(as % of GDP) of Moldova in 2009 and the Expenditure(as % of GDP) of Turkey in 2012?
Ensure brevity in your answer.  -0.4. What is the difference between the Expenditure(as % of GDP) of South Africa in 2009 and the Expenditure(as % of GDP) of Turkey in 2012?
Offer a very short reply. -0.09. What is the average Expenditure(as % of GDP) of Bosnia and Herzegovina per year?
Give a very brief answer. 0.05. What is the average Expenditure(as % of GDP) in Moldova per year?
Give a very brief answer. 0.44. What is the average Expenditure(as % of GDP) of South Africa per year?
Provide a short and direct response. 0.83. What is the average Expenditure(as % of GDP) of Turkey per year?
Your response must be concise. 0.67. In the year 2003, what is the difference between the Expenditure(as % of GDP) in Bosnia and Herzegovina and Expenditure(as % of GDP) in Moldova?
Provide a succinct answer. -0.31. In the year 2003, what is the difference between the Expenditure(as % of GDP) in Bosnia and Herzegovina and Expenditure(as % of GDP) in South Africa?
Offer a terse response. -0.74. In the year 2003, what is the difference between the Expenditure(as % of GDP) in Bosnia and Herzegovina and Expenditure(as % of GDP) in Turkey?
Make the answer very short. -0.46. In the year 2003, what is the difference between the Expenditure(as % of GDP) of Moldova and Expenditure(as % of GDP) of South Africa?
Provide a succinct answer. -0.44. In the year 2003, what is the difference between the Expenditure(as % of GDP) in Moldova and Expenditure(as % of GDP) in Turkey?
Your answer should be very brief. -0.16. In the year 2003, what is the difference between the Expenditure(as % of GDP) in South Africa and Expenditure(as % of GDP) in Turkey?
Offer a very short reply. 0.28. In the year 2004, what is the difference between the Expenditure(as % of GDP) of Bosnia and Herzegovina and Expenditure(as % of GDP) of Moldova?
Your answer should be compact. -0.33. In the year 2004, what is the difference between the Expenditure(as % of GDP) in Bosnia and Herzegovina and Expenditure(as % of GDP) in South Africa?
Provide a succinct answer. -0.8. In the year 2004, what is the difference between the Expenditure(as % of GDP) in Bosnia and Herzegovina and Expenditure(as % of GDP) in Turkey?
Offer a terse response. -0.5. In the year 2004, what is the difference between the Expenditure(as % of GDP) of Moldova and Expenditure(as % of GDP) of South Africa?
Offer a very short reply. -0.46. In the year 2004, what is the difference between the Expenditure(as % of GDP) in Moldova and Expenditure(as % of GDP) in Turkey?
Provide a short and direct response. -0.17. In the year 2004, what is the difference between the Expenditure(as % of GDP) of South Africa and Expenditure(as % of GDP) of Turkey?
Give a very brief answer. 0.29. In the year 2005, what is the difference between the Expenditure(as % of GDP) of Bosnia and Herzegovina and Expenditure(as % of GDP) of Moldova?
Offer a very short reply. -0.37. In the year 2005, what is the difference between the Expenditure(as % of GDP) of Bosnia and Herzegovina and Expenditure(as % of GDP) of South Africa?
Your answer should be compact. -0.84. In the year 2005, what is the difference between the Expenditure(as % of GDP) of Bosnia and Herzegovina and Expenditure(as % of GDP) of Turkey?
Offer a terse response. -0.56. In the year 2005, what is the difference between the Expenditure(as % of GDP) of Moldova and Expenditure(as % of GDP) of South Africa?
Your answer should be very brief. -0.46. In the year 2005, what is the difference between the Expenditure(as % of GDP) of Moldova and Expenditure(as % of GDP) of Turkey?
Offer a terse response. -0.19. In the year 2005, what is the difference between the Expenditure(as % of GDP) in South Africa and Expenditure(as % of GDP) in Turkey?
Offer a very short reply. 0.27. In the year 2006, what is the difference between the Expenditure(as % of GDP) in Bosnia and Herzegovina and Expenditure(as % of GDP) in Moldova?
Keep it short and to the point. -0.39. In the year 2006, what is the difference between the Expenditure(as % of GDP) of Bosnia and Herzegovina and Expenditure(as % of GDP) of South Africa?
Provide a short and direct response. -0.88. In the year 2006, what is the difference between the Expenditure(as % of GDP) in Bosnia and Herzegovina and Expenditure(as % of GDP) in Turkey?
Keep it short and to the point. -0.56. In the year 2006, what is the difference between the Expenditure(as % of GDP) of Moldova and Expenditure(as % of GDP) of South Africa?
Keep it short and to the point. -0.49. In the year 2006, what is the difference between the Expenditure(as % of GDP) of Moldova and Expenditure(as % of GDP) of Turkey?
Provide a succinct answer. -0.17. In the year 2006, what is the difference between the Expenditure(as % of GDP) in South Africa and Expenditure(as % of GDP) in Turkey?
Your response must be concise. 0.32. In the year 2007, what is the difference between the Expenditure(as % of GDP) in Bosnia and Herzegovina and Expenditure(as % of GDP) in Moldova?
Provide a succinct answer. -0.52. In the year 2007, what is the difference between the Expenditure(as % of GDP) of Bosnia and Herzegovina and Expenditure(as % of GDP) of South Africa?
Provide a succinct answer. -0.86. In the year 2007, what is the difference between the Expenditure(as % of GDP) of Bosnia and Herzegovina and Expenditure(as % of GDP) of Turkey?
Your response must be concise. -0.7. In the year 2007, what is the difference between the Expenditure(as % of GDP) in Moldova and Expenditure(as % of GDP) in South Africa?
Ensure brevity in your answer.  -0.34. In the year 2007, what is the difference between the Expenditure(as % of GDP) in Moldova and Expenditure(as % of GDP) in Turkey?
Your answer should be compact. -0.18. In the year 2007, what is the difference between the Expenditure(as % of GDP) of South Africa and Expenditure(as % of GDP) of Turkey?
Ensure brevity in your answer.  0.16. In the year 2008, what is the difference between the Expenditure(as % of GDP) of Bosnia and Herzegovina and Expenditure(as % of GDP) of Moldova?
Your answer should be very brief. -0.52. In the year 2008, what is the difference between the Expenditure(as % of GDP) of Bosnia and Herzegovina and Expenditure(as % of GDP) of South Africa?
Your answer should be very brief. -0.87. In the year 2008, what is the difference between the Expenditure(as % of GDP) in Bosnia and Herzegovina and Expenditure(as % of GDP) in Turkey?
Your response must be concise. -0.71. In the year 2008, what is the difference between the Expenditure(as % of GDP) of Moldova and Expenditure(as % of GDP) of South Africa?
Keep it short and to the point. -0.35. In the year 2008, what is the difference between the Expenditure(as % of GDP) in Moldova and Expenditure(as % of GDP) in Turkey?
Your answer should be compact. -0.19. In the year 2008, what is the difference between the Expenditure(as % of GDP) of South Africa and Expenditure(as % of GDP) of Turkey?
Keep it short and to the point. 0.16. In the year 2009, what is the difference between the Expenditure(as % of GDP) of Bosnia and Herzegovina and Expenditure(as % of GDP) of Moldova?
Give a very brief answer. -0.5. In the year 2009, what is the difference between the Expenditure(as % of GDP) in Bosnia and Herzegovina and Expenditure(as % of GDP) in South Africa?
Your answer should be compact. -0.81. In the year 2009, what is the difference between the Expenditure(as % of GDP) in Bosnia and Herzegovina and Expenditure(as % of GDP) in Turkey?
Give a very brief answer. -0.83. In the year 2009, what is the difference between the Expenditure(as % of GDP) in Moldova and Expenditure(as % of GDP) in South Africa?
Your answer should be very brief. -0.31. In the year 2009, what is the difference between the Expenditure(as % of GDP) of Moldova and Expenditure(as % of GDP) of Turkey?
Offer a terse response. -0.32. In the year 2009, what is the difference between the Expenditure(as % of GDP) in South Africa and Expenditure(as % of GDP) in Turkey?
Make the answer very short. -0.01. In the year 2012, what is the difference between the Expenditure(as % of GDP) of Bosnia and Herzegovina and Expenditure(as % of GDP) of Moldova?
Provide a short and direct response. -0.15. In the year 2012, what is the difference between the Expenditure(as % of GDP) in Bosnia and Herzegovina and Expenditure(as % of GDP) in South Africa?
Keep it short and to the point. -0.46. In the year 2012, what is the difference between the Expenditure(as % of GDP) of Bosnia and Herzegovina and Expenditure(as % of GDP) of Turkey?
Your answer should be very brief. -0.65. In the year 2012, what is the difference between the Expenditure(as % of GDP) of Moldova and Expenditure(as % of GDP) of South Africa?
Offer a terse response. -0.31. In the year 2012, what is the difference between the Expenditure(as % of GDP) in Moldova and Expenditure(as % of GDP) in Turkey?
Ensure brevity in your answer.  -0.5. In the year 2012, what is the difference between the Expenditure(as % of GDP) in South Africa and Expenditure(as % of GDP) in Turkey?
Offer a very short reply. -0.19. What is the ratio of the Expenditure(as % of GDP) in Bosnia and Herzegovina in 2003 to that in 2004?
Provide a short and direct response. 1.15. What is the ratio of the Expenditure(as % of GDP) of Moldova in 2003 to that in 2004?
Provide a succinct answer. 0.93. What is the ratio of the Expenditure(as % of GDP) in South Africa in 2003 to that in 2004?
Provide a short and direct response. 0.94. What is the ratio of the Expenditure(as % of GDP) in Turkey in 2003 to that in 2004?
Your answer should be compact. 0.93. What is the ratio of the Expenditure(as % of GDP) in Bosnia and Herzegovina in 2003 to that in 2005?
Ensure brevity in your answer.  0.67. What is the ratio of the Expenditure(as % of GDP) of Moldova in 2003 to that in 2005?
Provide a succinct answer. 0.81. What is the ratio of the Expenditure(as % of GDP) of South Africa in 2003 to that in 2005?
Provide a short and direct response. 0.88. What is the ratio of the Expenditure(as % of GDP) in Turkey in 2003 to that in 2005?
Offer a terse response. 0.82. What is the ratio of the Expenditure(as % of GDP) of Bosnia and Herzegovina in 2003 to that in 2006?
Provide a succinct answer. 0.92. What is the ratio of the Expenditure(as % of GDP) of Moldova in 2003 to that in 2006?
Make the answer very short. 0.8. What is the ratio of the Expenditure(as % of GDP) of South Africa in 2003 to that in 2006?
Provide a succinct answer. 0.85. What is the ratio of the Expenditure(as % of GDP) in Turkey in 2003 to that in 2006?
Your response must be concise. 0.83. What is the ratio of the Expenditure(as % of GDP) of Bosnia and Herzegovina in 2003 to that in 2007?
Your response must be concise. 0.72. What is the ratio of the Expenditure(as % of GDP) in Moldova in 2003 to that in 2007?
Your response must be concise. 0.59. What is the ratio of the Expenditure(as % of GDP) in South Africa in 2003 to that in 2007?
Provide a short and direct response. 0.86. What is the ratio of the Expenditure(as % of GDP) in Turkey in 2003 to that in 2007?
Provide a short and direct response. 0.67. What is the ratio of the Expenditure(as % of GDP) in Bosnia and Herzegovina in 2003 to that in 2008?
Your response must be concise. 0.99. What is the ratio of the Expenditure(as % of GDP) of Moldova in 2003 to that in 2008?
Your response must be concise. 0.61. What is the ratio of the Expenditure(as % of GDP) in South Africa in 2003 to that in 2008?
Make the answer very short. 0.86. What is the ratio of the Expenditure(as % of GDP) in Turkey in 2003 to that in 2008?
Offer a very short reply. 0.67. What is the ratio of the Expenditure(as % of GDP) in Bosnia and Herzegovina in 2003 to that in 2009?
Offer a terse response. 0.86. What is the ratio of the Expenditure(as % of GDP) in Moldova in 2003 to that in 2009?
Offer a terse response. 0.62. What is the ratio of the Expenditure(as % of GDP) in South Africa in 2003 to that in 2009?
Provide a short and direct response. 0.91. What is the ratio of the Expenditure(as % of GDP) in Turkey in 2003 to that in 2009?
Provide a succinct answer. 0.57. What is the ratio of the Expenditure(as % of GDP) in Bosnia and Herzegovina in 2003 to that in 2012?
Offer a terse response. 0.07. What is the ratio of the Expenditure(as % of GDP) in Moldova in 2003 to that in 2012?
Keep it short and to the point. 0.78. What is the ratio of the Expenditure(as % of GDP) in South Africa in 2003 to that in 2012?
Provide a succinct answer. 1.04. What is the ratio of the Expenditure(as % of GDP) of Turkey in 2003 to that in 2012?
Your response must be concise. 0.52. What is the ratio of the Expenditure(as % of GDP) in Bosnia and Herzegovina in 2004 to that in 2005?
Your answer should be compact. 0.58. What is the ratio of the Expenditure(as % of GDP) in Moldova in 2004 to that in 2005?
Keep it short and to the point. 0.88. What is the ratio of the Expenditure(as % of GDP) of South Africa in 2004 to that in 2005?
Give a very brief answer. 0.94. What is the ratio of the Expenditure(as % of GDP) in Turkey in 2004 to that in 2005?
Provide a short and direct response. 0.88. What is the ratio of the Expenditure(as % of GDP) of Bosnia and Herzegovina in 2004 to that in 2006?
Offer a terse response. 0.8. What is the ratio of the Expenditure(as % of GDP) in Moldova in 2004 to that in 2006?
Make the answer very short. 0.86. What is the ratio of the Expenditure(as % of GDP) of South Africa in 2004 to that in 2006?
Provide a succinct answer. 0.91. What is the ratio of the Expenditure(as % of GDP) of Turkey in 2004 to that in 2006?
Make the answer very short. 0.89. What is the ratio of the Expenditure(as % of GDP) in Bosnia and Herzegovina in 2004 to that in 2007?
Ensure brevity in your answer.  0.63. What is the ratio of the Expenditure(as % of GDP) of Moldova in 2004 to that in 2007?
Your answer should be very brief. 0.64. What is the ratio of the Expenditure(as % of GDP) of South Africa in 2004 to that in 2007?
Your answer should be very brief. 0.92. What is the ratio of the Expenditure(as % of GDP) of Turkey in 2004 to that in 2007?
Provide a short and direct response. 0.72. What is the ratio of the Expenditure(as % of GDP) of Bosnia and Herzegovina in 2004 to that in 2008?
Make the answer very short. 0.86. What is the ratio of the Expenditure(as % of GDP) of Moldova in 2004 to that in 2008?
Keep it short and to the point. 0.65. What is the ratio of the Expenditure(as % of GDP) of South Africa in 2004 to that in 2008?
Your response must be concise. 0.92. What is the ratio of the Expenditure(as % of GDP) of Turkey in 2004 to that in 2008?
Your response must be concise. 0.71. What is the ratio of the Expenditure(as % of GDP) in Moldova in 2004 to that in 2009?
Provide a short and direct response. 0.66. What is the ratio of the Expenditure(as % of GDP) in South Africa in 2004 to that in 2009?
Your answer should be compact. 0.97. What is the ratio of the Expenditure(as % of GDP) of Turkey in 2004 to that in 2009?
Your answer should be compact. 0.61. What is the ratio of the Expenditure(as % of GDP) of Bosnia and Herzegovina in 2004 to that in 2012?
Your answer should be compact. 0.06. What is the ratio of the Expenditure(as % of GDP) in Moldova in 2004 to that in 2012?
Offer a very short reply. 0.84. What is the ratio of the Expenditure(as % of GDP) of South Africa in 2004 to that in 2012?
Offer a very short reply. 1.11. What is the ratio of the Expenditure(as % of GDP) in Turkey in 2004 to that in 2012?
Your answer should be compact. 0.56. What is the ratio of the Expenditure(as % of GDP) of Bosnia and Herzegovina in 2005 to that in 2006?
Provide a succinct answer. 1.38. What is the ratio of the Expenditure(as % of GDP) in Moldova in 2005 to that in 2006?
Ensure brevity in your answer.  0.98. What is the ratio of the Expenditure(as % of GDP) of Turkey in 2005 to that in 2006?
Your answer should be compact. 1.02. What is the ratio of the Expenditure(as % of GDP) of Bosnia and Herzegovina in 2005 to that in 2007?
Provide a short and direct response. 1.08. What is the ratio of the Expenditure(as % of GDP) of Moldova in 2005 to that in 2007?
Provide a succinct answer. 0.73. What is the ratio of the Expenditure(as % of GDP) of South Africa in 2005 to that in 2007?
Give a very brief answer. 0.98. What is the ratio of the Expenditure(as % of GDP) of Turkey in 2005 to that in 2007?
Give a very brief answer. 0.82. What is the ratio of the Expenditure(as % of GDP) in Bosnia and Herzegovina in 2005 to that in 2008?
Your response must be concise. 1.48. What is the ratio of the Expenditure(as % of GDP) of Moldova in 2005 to that in 2008?
Your answer should be compact. 0.75. What is the ratio of the Expenditure(as % of GDP) of South Africa in 2005 to that in 2008?
Your response must be concise. 0.97. What is the ratio of the Expenditure(as % of GDP) in Turkey in 2005 to that in 2008?
Keep it short and to the point. 0.81. What is the ratio of the Expenditure(as % of GDP) in Bosnia and Herzegovina in 2005 to that in 2009?
Offer a terse response. 1.29. What is the ratio of the Expenditure(as % of GDP) in Moldova in 2005 to that in 2009?
Ensure brevity in your answer.  0.76. What is the ratio of the Expenditure(as % of GDP) of South Africa in 2005 to that in 2009?
Ensure brevity in your answer.  1.03. What is the ratio of the Expenditure(as % of GDP) in Turkey in 2005 to that in 2009?
Offer a very short reply. 0.7. What is the ratio of the Expenditure(as % of GDP) in Bosnia and Herzegovina in 2005 to that in 2012?
Make the answer very short. 0.1. What is the ratio of the Expenditure(as % of GDP) of Moldova in 2005 to that in 2012?
Ensure brevity in your answer.  0.96. What is the ratio of the Expenditure(as % of GDP) of South Africa in 2005 to that in 2012?
Provide a succinct answer. 1.18. What is the ratio of the Expenditure(as % of GDP) in Turkey in 2005 to that in 2012?
Your answer should be compact. 0.64. What is the ratio of the Expenditure(as % of GDP) in Bosnia and Herzegovina in 2006 to that in 2007?
Offer a terse response. 0.78. What is the ratio of the Expenditure(as % of GDP) of Moldova in 2006 to that in 2007?
Make the answer very short. 0.74. What is the ratio of the Expenditure(as % of GDP) of South Africa in 2006 to that in 2007?
Offer a terse response. 1.02. What is the ratio of the Expenditure(as % of GDP) in Turkey in 2006 to that in 2007?
Your answer should be compact. 0.8. What is the ratio of the Expenditure(as % of GDP) of Bosnia and Herzegovina in 2006 to that in 2008?
Provide a short and direct response. 1.07. What is the ratio of the Expenditure(as % of GDP) in Moldova in 2006 to that in 2008?
Your answer should be compact. 0.76. What is the ratio of the Expenditure(as % of GDP) of South Africa in 2006 to that in 2008?
Provide a succinct answer. 1.01. What is the ratio of the Expenditure(as % of GDP) in Turkey in 2006 to that in 2008?
Your response must be concise. 0.8. What is the ratio of the Expenditure(as % of GDP) in Bosnia and Herzegovina in 2006 to that in 2009?
Provide a succinct answer. 0.94. What is the ratio of the Expenditure(as % of GDP) of Moldova in 2006 to that in 2009?
Your answer should be very brief. 0.77. What is the ratio of the Expenditure(as % of GDP) in South Africa in 2006 to that in 2009?
Your answer should be compact. 1.07. What is the ratio of the Expenditure(as % of GDP) of Turkey in 2006 to that in 2009?
Keep it short and to the point. 0.68. What is the ratio of the Expenditure(as % of GDP) of Bosnia and Herzegovina in 2006 to that in 2012?
Provide a succinct answer. 0.07. What is the ratio of the Expenditure(as % of GDP) of Moldova in 2006 to that in 2012?
Offer a terse response. 0.97. What is the ratio of the Expenditure(as % of GDP) in South Africa in 2006 to that in 2012?
Your response must be concise. 1.23. What is the ratio of the Expenditure(as % of GDP) of Turkey in 2006 to that in 2012?
Your answer should be compact. 0.63. What is the ratio of the Expenditure(as % of GDP) of Bosnia and Herzegovina in 2007 to that in 2008?
Provide a succinct answer. 1.37. What is the ratio of the Expenditure(as % of GDP) of Moldova in 2007 to that in 2008?
Your response must be concise. 1.02. What is the ratio of the Expenditure(as % of GDP) of Bosnia and Herzegovina in 2007 to that in 2009?
Ensure brevity in your answer.  1.2. What is the ratio of the Expenditure(as % of GDP) in Moldova in 2007 to that in 2009?
Offer a terse response. 1.04. What is the ratio of the Expenditure(as % of GDP) of South Africa in 2007 to that in 2009?
Keep it short and to the point. 1.06. What is the ratio of the Expenditure(as % of GDP) in Turkey in 2007 to that in 2009?
Provide a short and direct response. 0.85. What is the ratio of the Expenditure(as % of GDP) in Bosnia and Herzegovina in 2007 to that in 2012?
Offer a very short reply. 0.1. What is the ratio of the Expenditure(as % of GDP) of Moldova in 2007 to that in 2012?
Offer a very short reply. 1.31. What is the ratio of the Expenditure(as % of GDP) of South Africa in 2007 to that in 2012?
Give a very brief answer. 1.21. What is the ratio of the Expenditure(as % of GDP) of Turkey in 2007 to that in 2012?
Your answer should be compact. 0.78. What is the ratio of the Expenditure(as % of GDP) of Bosnia and Herzegovina in 2008 to that in 2009?
Your response must be concise. 0.88. What is the ratio of the Expenditure(as % of GDP) in Moldova in 2008 to that in 2009?
Keep it short and to the point. 1.02. What is the ratio of the Expenditure(as % of GDP) of South Africa in 2008 to that in 2009?
Provide a succinct answer. 1.06. What is the ratio of the Expenditure(as % of GDP) in Turkey in 2008 to that in 2009?
Offer a terse response. 0.85. What is the ratio of the Expenditure(as % of GDP) of Bosnia and Herzegovina in 2008 to that in 2012?
Offer a very short reply. 0.07. What is the ratio of the Expenditure(as % of GDP) of Moldova in 2008 to that in 2012?
Offer a terse response. 1.28. What is the ratio of the Expenditure(as % of GDP) of South Africa in 2008 to that in 2012?
Give a very brief answer. 1.21. What is the ratio of the Expenditure(as % of GDP) in Turkey in 2008 to that in 2012?
Offer a terse response. 0.79. What is the ratio of the Expenditure(as % of GDP) in Bosnia and Herzegovina in 2009 to that in 2012?
Keep it short and to the point. 0.08. What is the ratio of the Expenditure(as % of GDP) in Moldova in 2009 to that in 2012?
Give a very brief answer. 1.26. What is the ratio of the Expenditure(as % of GDP) of South Africa in 2009 to that in 2012?
Provide a succinct answer. 1.14. What is the ratio of the Expenditure(as % of GDP) of Turkey in 2009 to that in 2012?
Offer a very short reply. 0.92. What is the difference between the highest and the second highest Expenditure(as % of GDP) of Bosnia and Herzegovina?
Offer a very short reply. 0.24. What is the difference between the highest and the second highest Expenditure(as % of GDP) in Moldova?
Offer a very short reply. 0.01. What is the difference between the highest and the second highest Expenditure(as % of GDP) in South Africa?
Make the answer very short. 0.01. What is the difference between the highest and the second highest Expenditure(as % of GDP) in Turkey?
Your answer should be compact. 0.07. What is the difference between the highest and the lowest Expenditure(as % of GDP) of Bosnia and Herzegovina?
Provide a succinct answer. 0.25. What is the difference between the highest and the lowest Expenditure(as % of GDP) of Moldova?
Your answer should be compact. 0.22. What is the difference between the highest and the lowest Expenditure(as % of GDP) of South Africa?
Offer a terse response. 0.17. What is the difference between the highest and the lowest Expenditure(as % of GDP) of Turkey?
Keep it short and to the point. 0.44. 